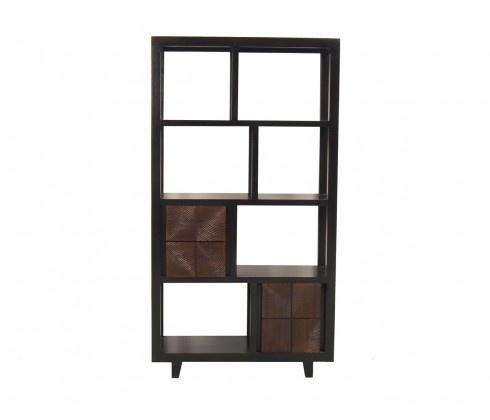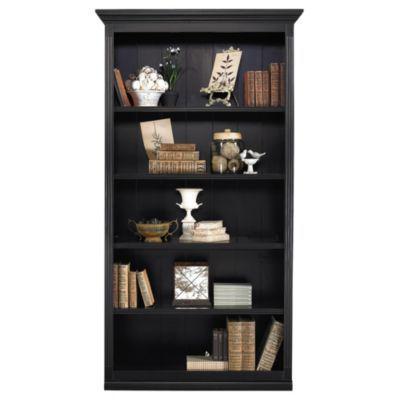The first image is the image on the left, the second image is the image on the right. Analyze the images presented: Is the assertion "Both shelf units can stand on their own." valid? Answer yes or no. Yes. The first image is the image on the left, the second image is the image on the right. Assess this claim about the two images: "The left image shows a dark bookcase with short legs, a top part that is open, and a bottom part at least partly closed.". Correct or not? Answer yes or no. Yes. 